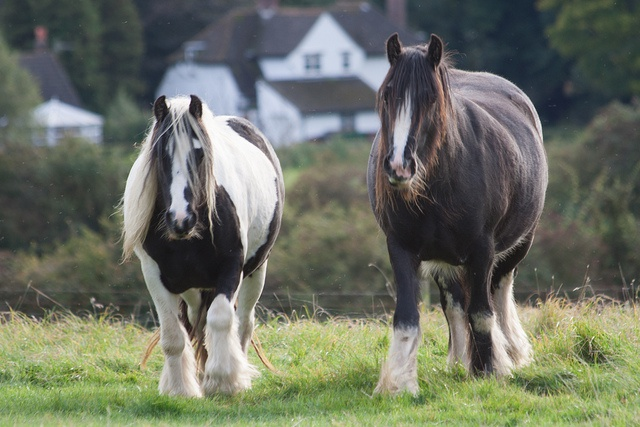Describe the objects in this image and their specific colors. I can see horse in black, gray, and darkgray tones and horse in black, lightgray, darkgray, and gray tones in this image. 